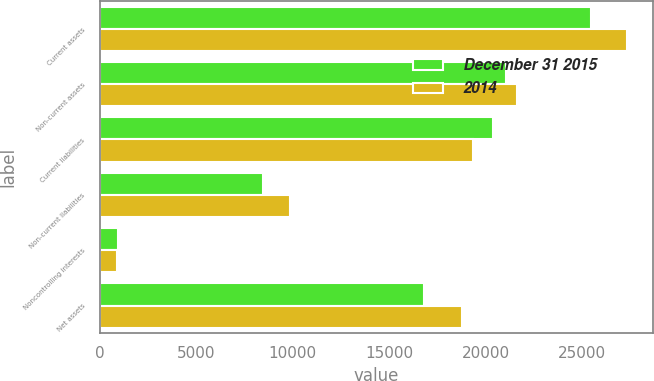Convert chart to OTSL. <chart><loc_0><loc_0><loc_500><loc_500><stacked_bar_chart><ecel><fcel>Current assets<fcel>Non-current assets<fcel>Current liabilities<fcel>Non-current liabilities<fcel>Noncontrolling interests<fcel>Net assets<nl><fcel>December 31 2015<fcel>25475<fcel>21077<fcel>20362<fcel>8449<fcel>947<fcel>16794<nl><fcel>2014<fcel>27307<fcel>21624<fcel>19370<fcel>9882<fcel>897<fcel>18782<nl></chart> 